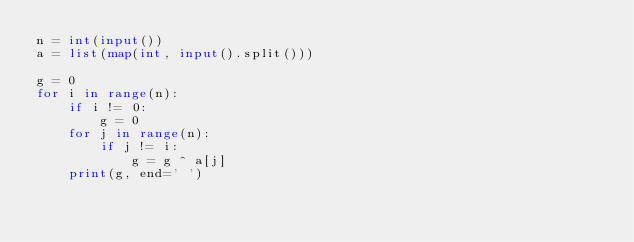Convert code to text. <code><loc_0><loc_0><loc_500><loc_500><_Python_>n = int(input())
a = list(map(int, input().split()))

g = 0
for i in range(n):
    if i != 0:
        g = 0
    for j in range(n):
        if j != i:
            g = g ^ a[j]
    print(g, end=' ')</code> 